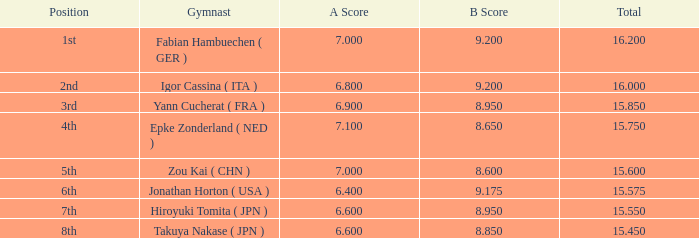95 and an a score lesser than Hiroyuki Tomita ( JPN ). 